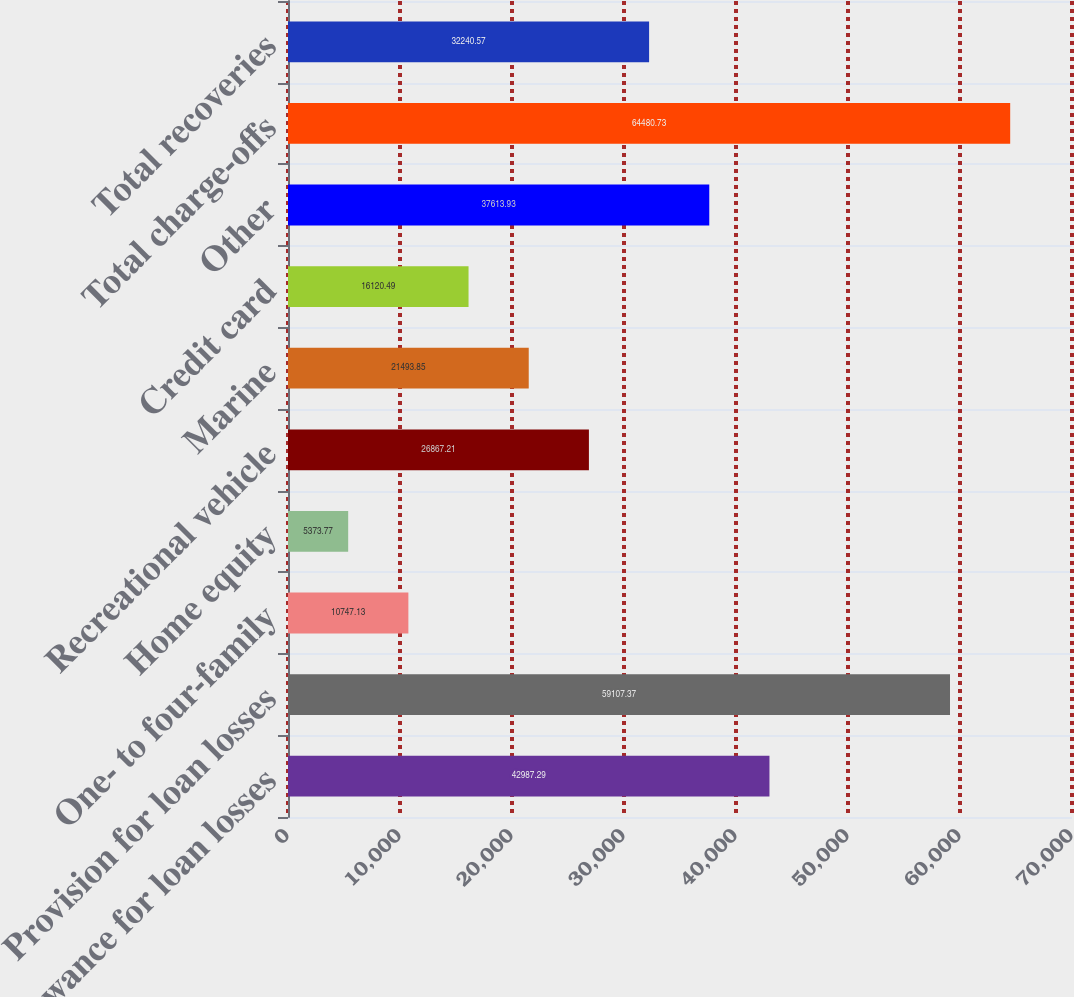<chart> <loc_0><loc_0><loc_500><loc_500><bar_chart><fcel>Allowance for loan losses<fcel>Provision for loan losses<fcel>One- to four-family<fcel>Home equity<fcel>Recreational vehicle<fcel>Marine<fcel>Credit card<fcel>Other<fcel>Total charge-offs<fcel>Total recoveries<nl><fcel>42987.3<fcel>59107.4<fcel>10747.1<fcel>5373.77<fcel>26867.2<fcel>21493.8<fcel>16120.5<fcel>37613.9<fcel>64480.7<fcel>32240.6<nl></chart> 